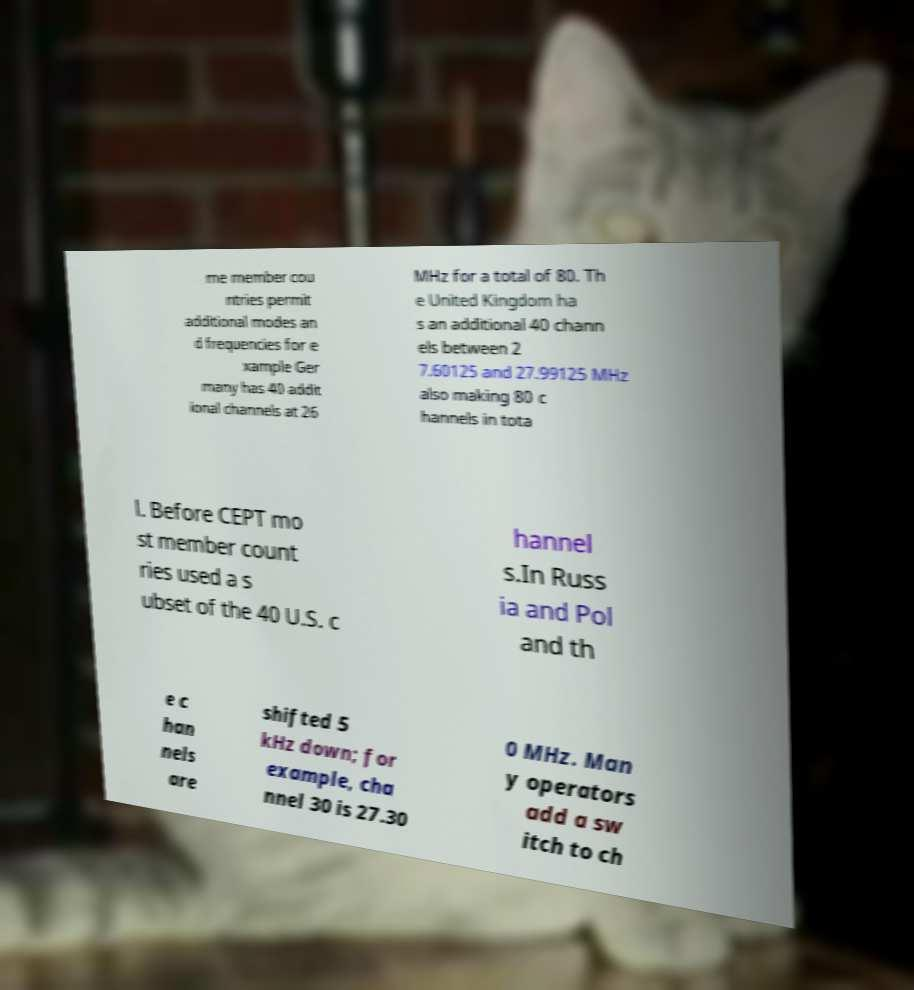What messages or text are displayed in this image? I need them in a readable, typed format. me member cou ntries permit additional modes an d frequencies for e xample Ger many has 40 addit ional channels at 26 MHz for a total of 80. Th e United Kingdom ha s an additional 40 chann els between 2 7.60125 and 27.99125 MHz also making 80 c hannels in tota l. Before CEPT mo st member count ries used a s ubset of the 40 U.S. c hannel s.In Russ ia and Pol and th e c han nels are shifted 5 kHz down; for example, cha nnel 30 is 27.30 0 MHz. Man y operators add a sw itch to ch 